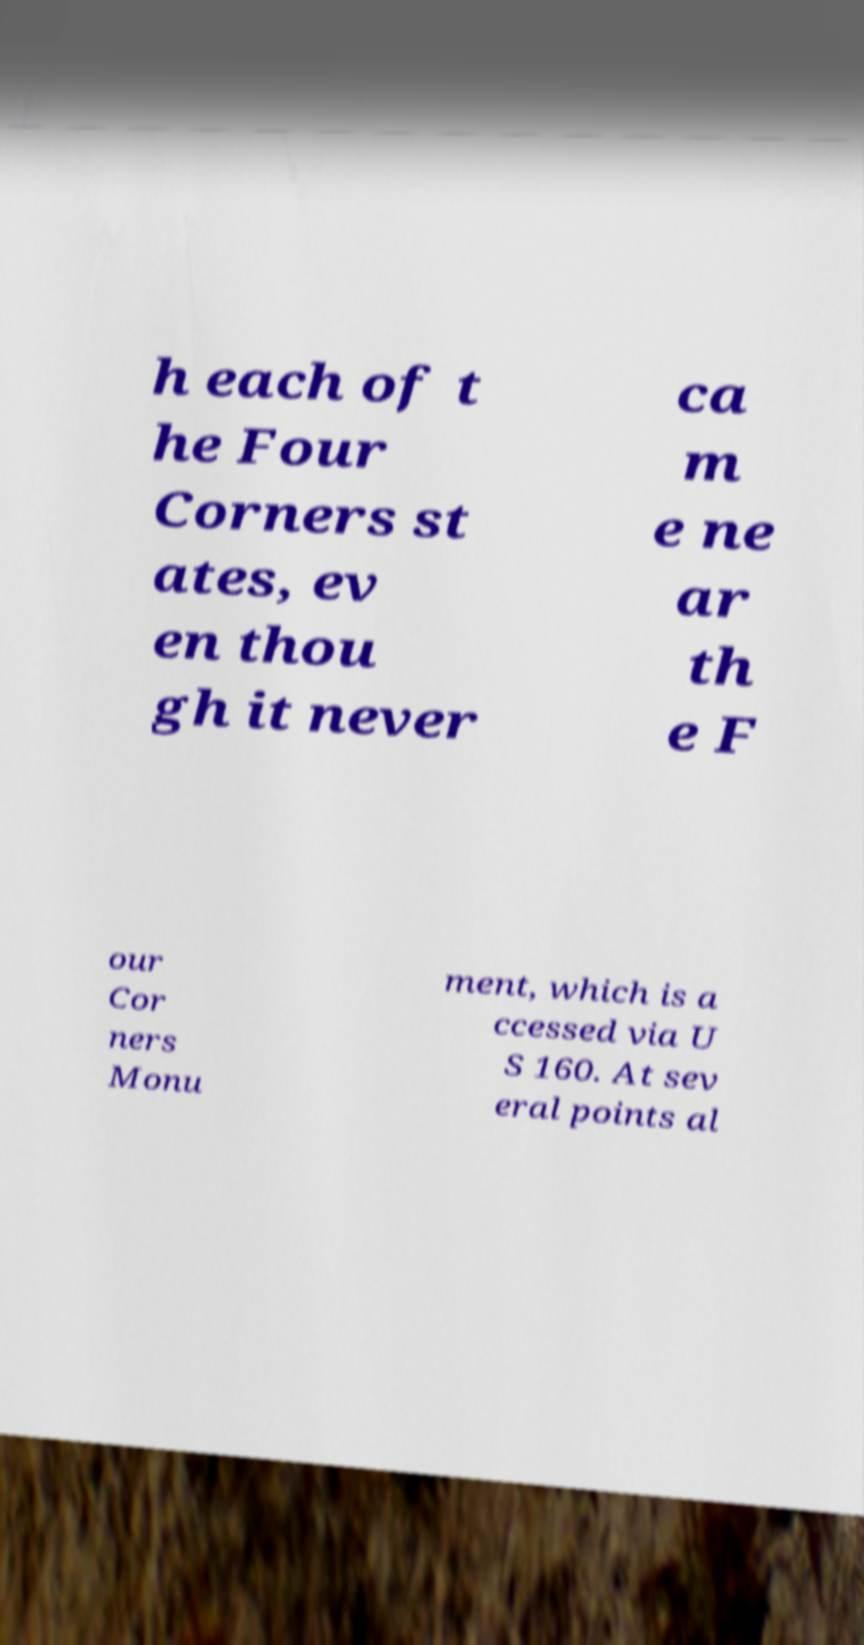Please read and relay the text visible in this image. What does it say? h each of t he Four Corners st ates, ev en thou gh it never ca m e ne ar th e F our Cor ners Monu ment, which is a ccessed via U S 160. At sev eral points al 